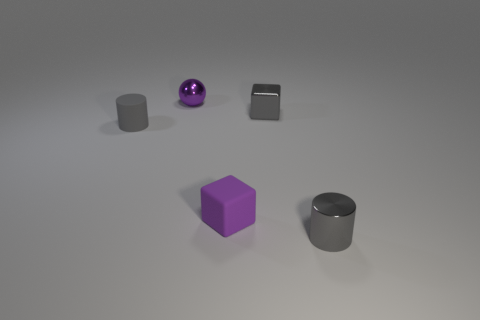What number of other objects are the same color as the ball?
Your answer should be compact. 1. What is the color of the tiny thing that is in front of the matte cylinder and to the right of the small matte cube?
Provide a short and direct response. Gray. How many small cylinders are there?
Your answer should be very brief. 2. Is the purple cube made of the same material as the tiny gray block?
Provide a succinct answer. No. What is the shape of the small thing to the left of the small purple metallic object that is to the left of the cube in front of the rubber cylinder?
Provide a succinct answer. Cylinder. Is the material of the small cylinder that is in front of the gray matte cylinder the same as the tiny block that is in front of the small matte cylinder?
Provide a succinct answer. No. What is the material of the tiny ball?
Keep it short and to the point. Metal. What number of other things are the same shape as the tiny purple matte thing?
Offer a very short reply. 1. There is another tiny cylinder that is the same color as the shiny cylinder; what is its material?
Your answer should be very brief. Rubber. Are there any other things that have the same shape as the purple metallic object?
Make the answer very short. No. 